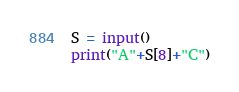<code> <loc_0><loc_0><loc_500><loc_500><_Python_>S = input()
print("A"+S[8]+"C")</code> 